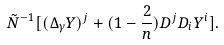<formula> <loc_0><loc_0><loc_500><loc_500>\tilde { N } ^ { - 1 } [ ( \Delta _ { \gamma } Y ) ^ { j } + ( 1 - \frac { 2 } { n } ) D ^ { j } D _ { i } Y ^ { i } ] .</formula> 